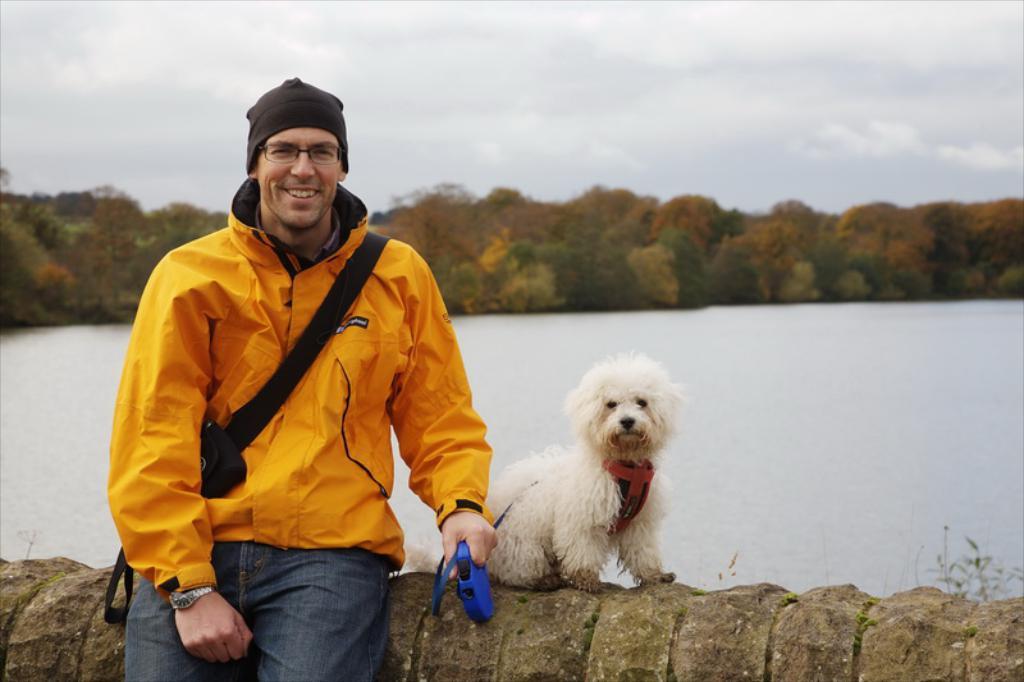In one or two sentences, can you explain what this image depicts? This is the picture outside of the city. There is a person sitting and smiling and there is a dog sitting on the wall. At the back there is a water and trees, at the top there is a sky with clouds. 